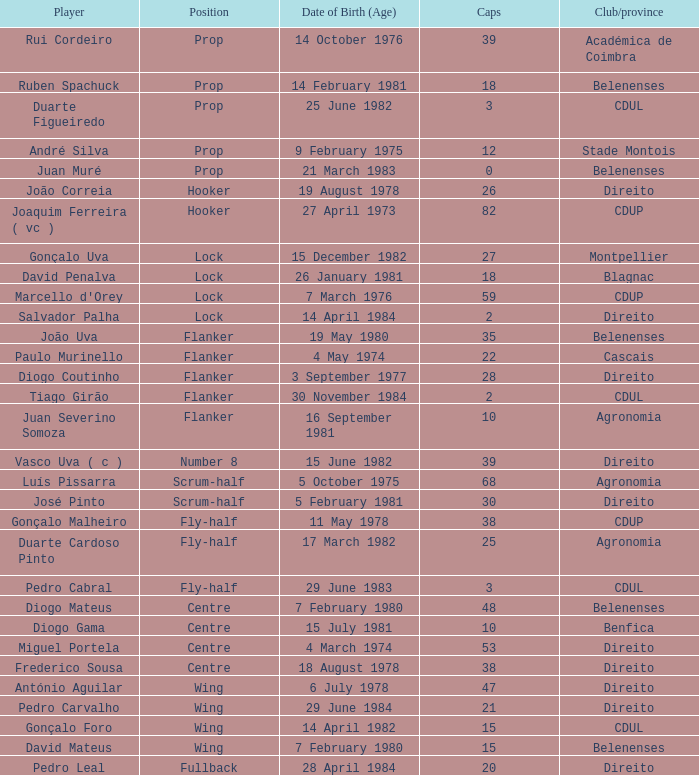How many caps have a Date of Birth (Age) of 15 july 1981? 1.0. 